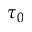Convert formula to latex. <formula><loc_0><loc_0><loc_500><loc_500>\tau _ { 0 }</formula> 